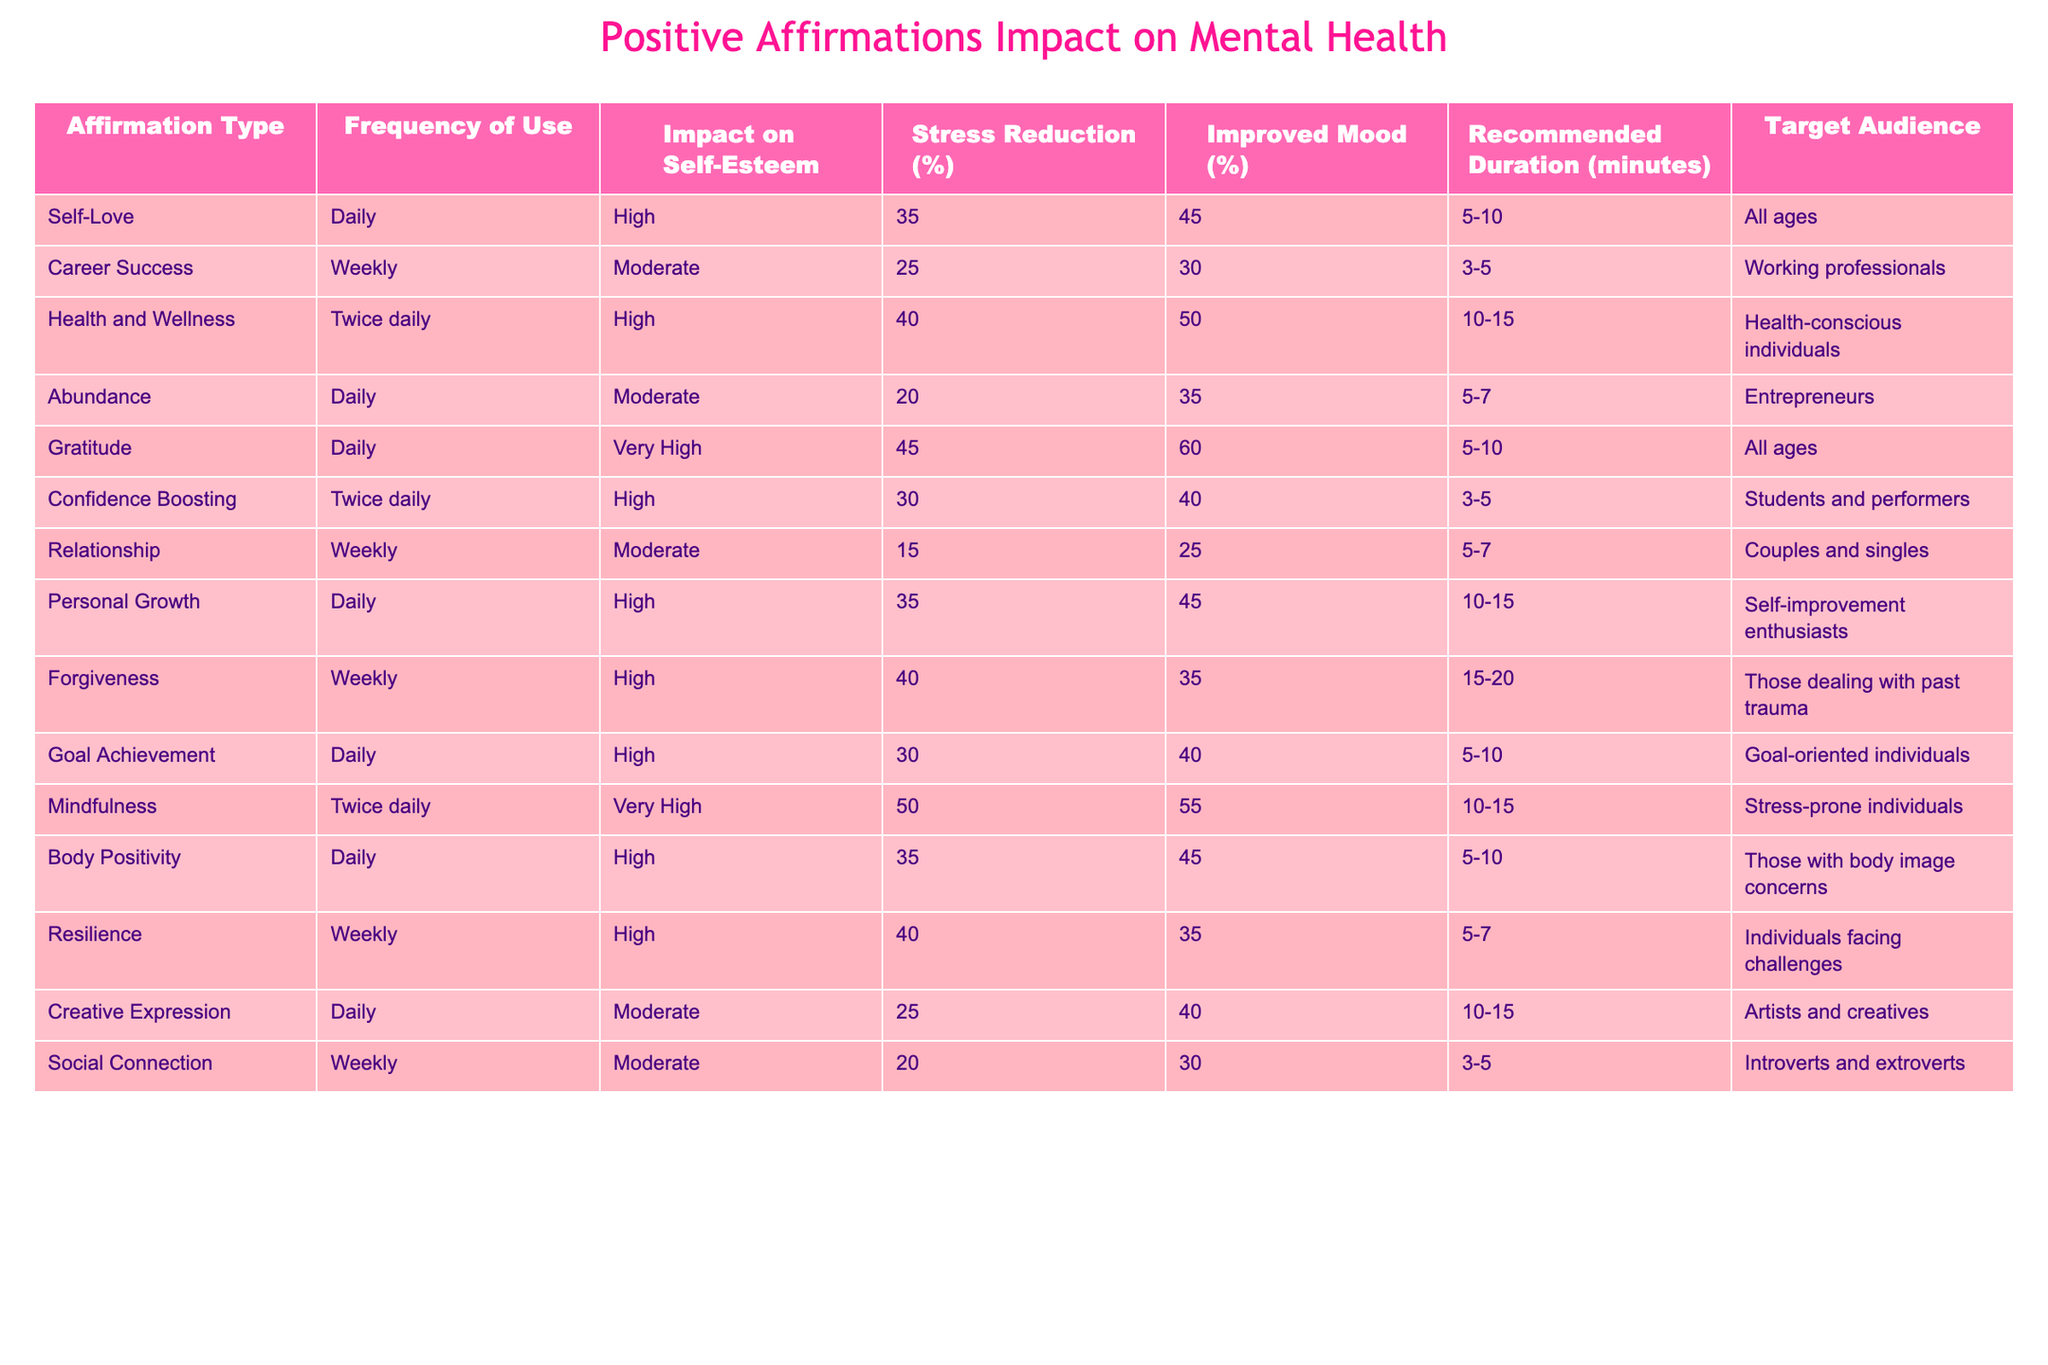What affirmation type has the highest impact on self-esteem? By looking at the "Impact on Self-Esteem" column, we see that "Gratitude" is marked as "Very High." That is the highest ranking on this scale.
Answer: Gratitude What is the stress reduction percentage for the affirmation type "Mindfulness"? The "Stress Reduction (%)" column indicates that "Mindfulness" achieves a 50% reduction in stress levels.
Answer: 50% How many minutes is recommended daily for "Health and Wellness" affirmations? The "Recommended Duration (minutes)" column shows that "Health and Wellness" affirmations are recommended for 10-15 minutes.
Answer: 10-15 True or False: "Creative Expression" affirmations have a moderate impact on improved mood. Looking at the "Improved Mood (%)" column, "Creative Expression" has a 40% improvement, which means it does indeed fall under the moderate category.
Answer: True What is the total impact on self-esteem for all affirmation types that are used daily? The "Impact on Self-Esteem" for daily affirmations are "High" for Self-Love, Health and Wellness, Confidence Boosting, Personal Growth, Goal Achievement, and Body Positivity, translating to 5 high impacts. We don’t have numerical values, but it’s clear there are multiple high impacts.
Answer: 5 